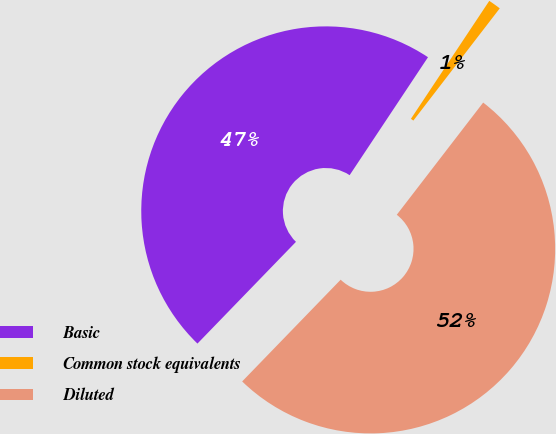Convert chart. <chart><loc_0><loc_0><loc_500><loc_500><pie_chart><fcel>Basic<fcel>Common stock equivalents<fcel>Diluted<nl><fcel>47.09%<fcel>1.11%<fcel>51.8%<nl></chart> 